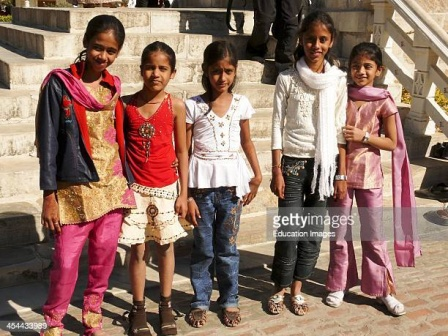What do you think is going on in this snapshot? In the image, five young girls are standing on a set of stone stairs. Each girl is wearing a unique outfit. The girl on the far left is dressed in a pink and gold outfit, smiling brightly. Beside her, the second girl wears red and gold, standing out vividly against the background. The girl in the middle has on a white blouse with jeans, presenting a casual yet stylish look. The fourth girl is dressed in a white top with a distinctive white scarf, adding an element of elegance. Finally, the girl on the far right wears a pink and gold outfit similar to the first girl, making a symmetrical aesthetic for the group. Their diverse clothing styles and cheerful expressions suggest a moment of celebration or a casual gathering. The stone stairs and railing in the background add depth and context to this joyful scene. 